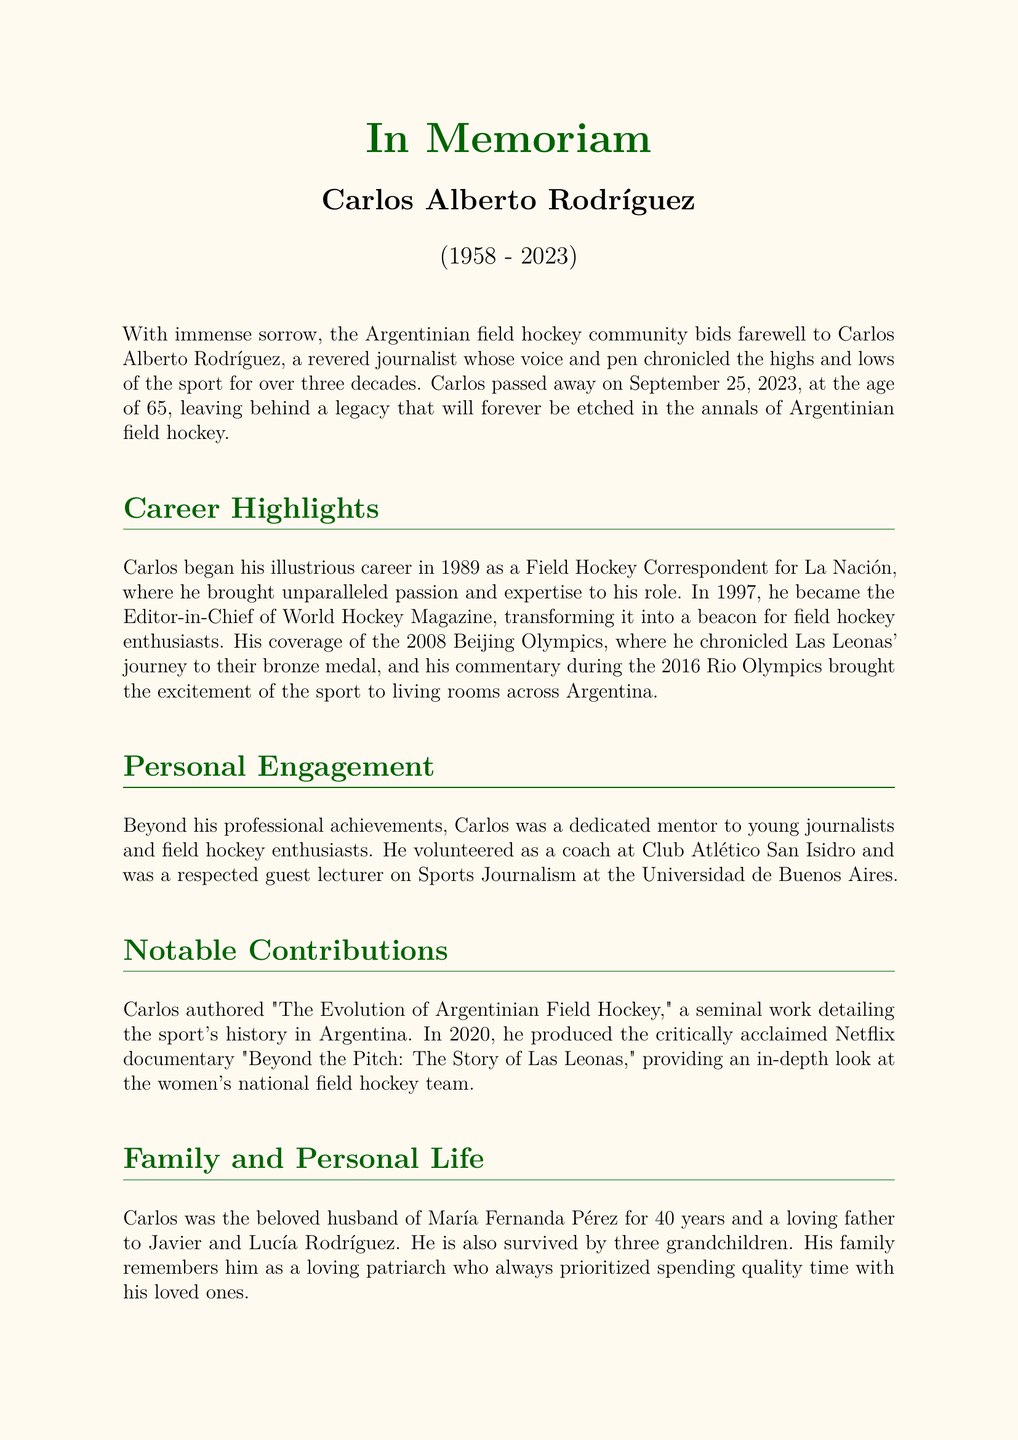What year did Carlos begin his career? Carlos began his career in 1989 as a Field Hockey Correspondent for La Nación.
Answer: 1989 How many years did Carlos work in field hockey journalism? Carlos worked for over three decades, which equates to more than 30 years in journalism.
Answer: Over three decades What significant event did Carlos cover in 2008? Carlos chronicled Las Leonas' journey to their bronze medal during the 2008 Beijing Olympics.
Answer: 2008 Beijing Olympics Who was Carlos' wife? Carlos was the beloved husband of María Fernanda Pérez for 40 years.
Answer: María Fernanda Pérez What is the title of Carlos' notable book? Carlos authored "The Evolution of Argentinian Field Hockey," detailing the sport's history.
Answer: The Evolution of Argentinian Field Hockey What documentary did Carlos produce in 2020? Carlos produced the critically acclaimed Netflix documentary "Beyond the Pitch: The Story of Las Leonas" in 2020.
Answer: Beyond the Pitch: The Story of Las Leonas How many grandchildren did Carlos have? Carlos is survived by three grandchildren.
Answer: Three What role did Carlos serve at Club Atlético San Isidro? Carlos volunteered as a coach at Club Atlético San Isidro, engaging personally with the sport.
Answer: Coach What legacy did Carlos leave in the field hockey community? Carlos' storytelling and commitment elevated the game and inspired future generations.
Answer: Indelible legacy 